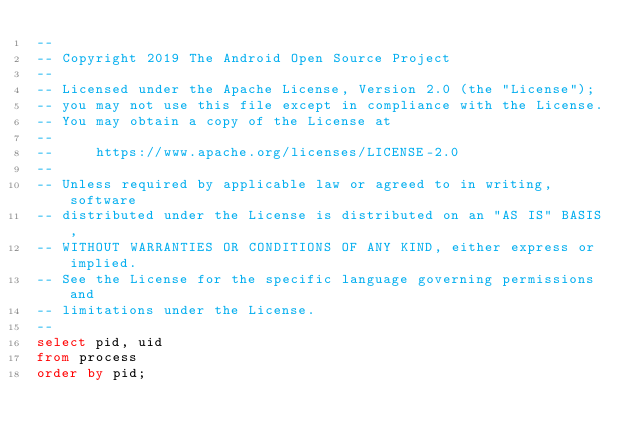<code> <loc_0><loc_0><loc_500><loc_500><_SQL_>--
-- Copyright 2019 The Android Open Source Project
--
-- Licensed under the Apache License, Version 2.0 (the "License");
-- you may not use this file except in compliance with the License.
-- You may obtain a copy of the License at
--
--     https://www.apache.org/licenses/LICENSE-2.0
--
-- Unless required by applicable law or agreed to in writing, software
-- distributed under the License is distributed on an "AS IS" BASIS,
-- WITHOUT WARRANTIES OR CONDITIONS OF ANY KIND, either express or implied.
-- See the License for the specific language governing permissions and
-- limitations under the License.
--
select pid, uid
from process
order by pid;
</code> 